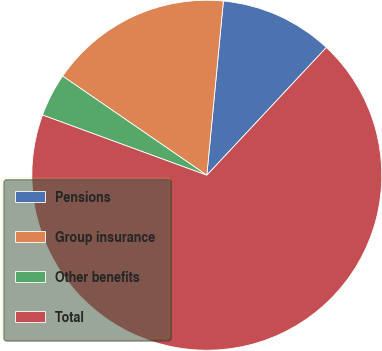Convert chart. <chart><loc_0><loc_0><loc_500><loc_500><pie_chart><fcel>Pensions<fcel>Group insurance<fcel>Other benefits<fcel>Total<nl><fcel>10.46%<fcel>16.92%<fcel>4.0%<fcel>68.62%<nl></chart> 